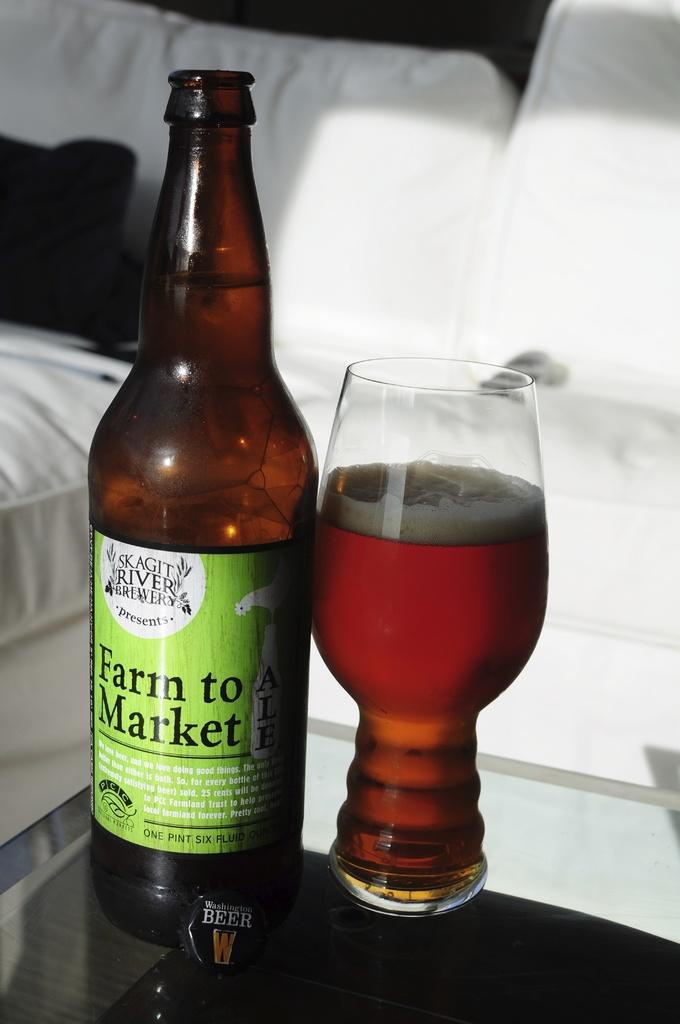What is the main object in the center of the image? There is a bottle in the center of the image. What is on the table in the image? There is a glass filled with wine on the table. What can be seen in the background of the image? There is a sofa in the background of the image. Is there a scarf draped over the sofa in the image? There is no mention of a scarf in the image, so it cannot be determined if one is draped over the sofa. 